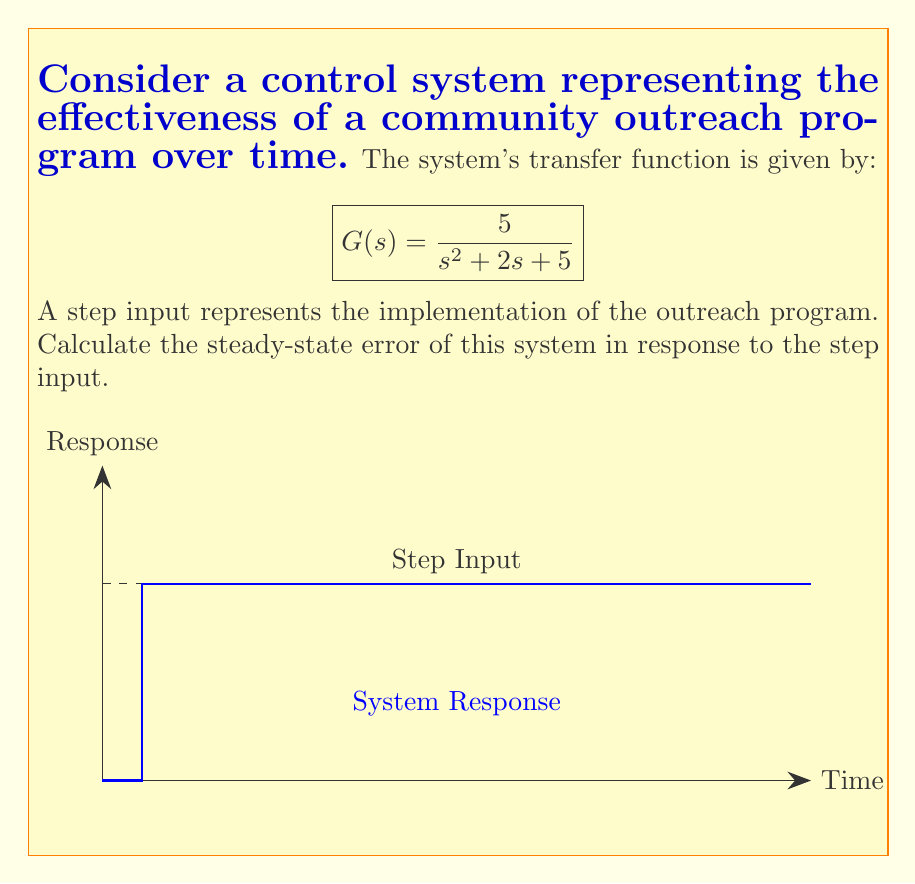Teach me how to tackle this problem. To evaluate the steady-state error for a step input, we follow these steps:

1) The steady-state error for a step input is given by:

   $$e_{ss} = \frac{1}{1 + \lim_{s \to 0} sG(s)}$$

2) First, we calculate $\lim_{s \to 0} sG(s)$:

   $$\lim_{s \to 0} sG(s) = \lim_{s \to 0} \frac{5s}{s^2 + 2s + 5}$$

3) Applying L'Hôpital's rule:

   $$\lim_{s \to 0} \frac{5s}{s^2 + 2s + 5} = \lim_{s \to 0} \frac{5}{2s + 2} = \frac{5}{2}$$

4) Now we can calculate the steady-state error:

   $$e_{ss} = \frac{1}{1 + \frac{5}{2}} = \frac{1}{\frac{7}{2}} = \frac{2}{7}$$

5) To express this as a percentage:

   $$e_{ss} (\%) = \frac{2}{7} \times 100\% \approx 28.57\%$$

This result indicates that the community outreach program, while effective, still has room for improvement in its long-term impact.
Answer: $\frac{2}{7}$ or approximately 28.57% 